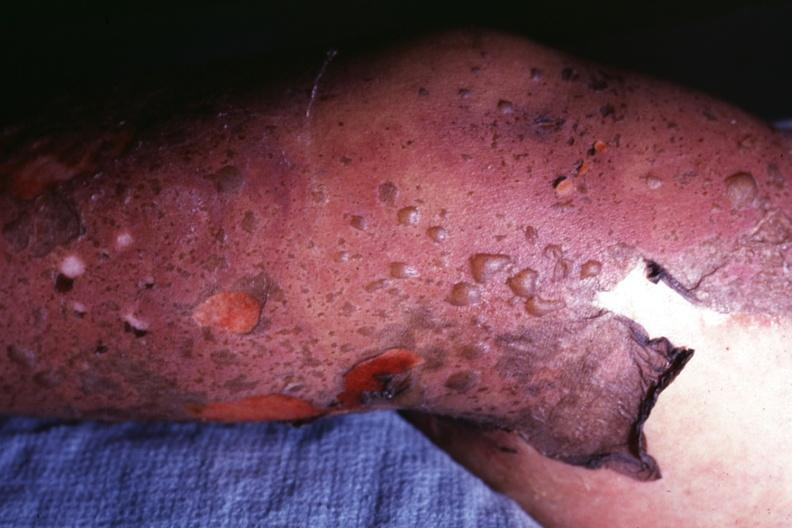what is this it looks like?
Answer the question using a single word or phrase. Sure what 